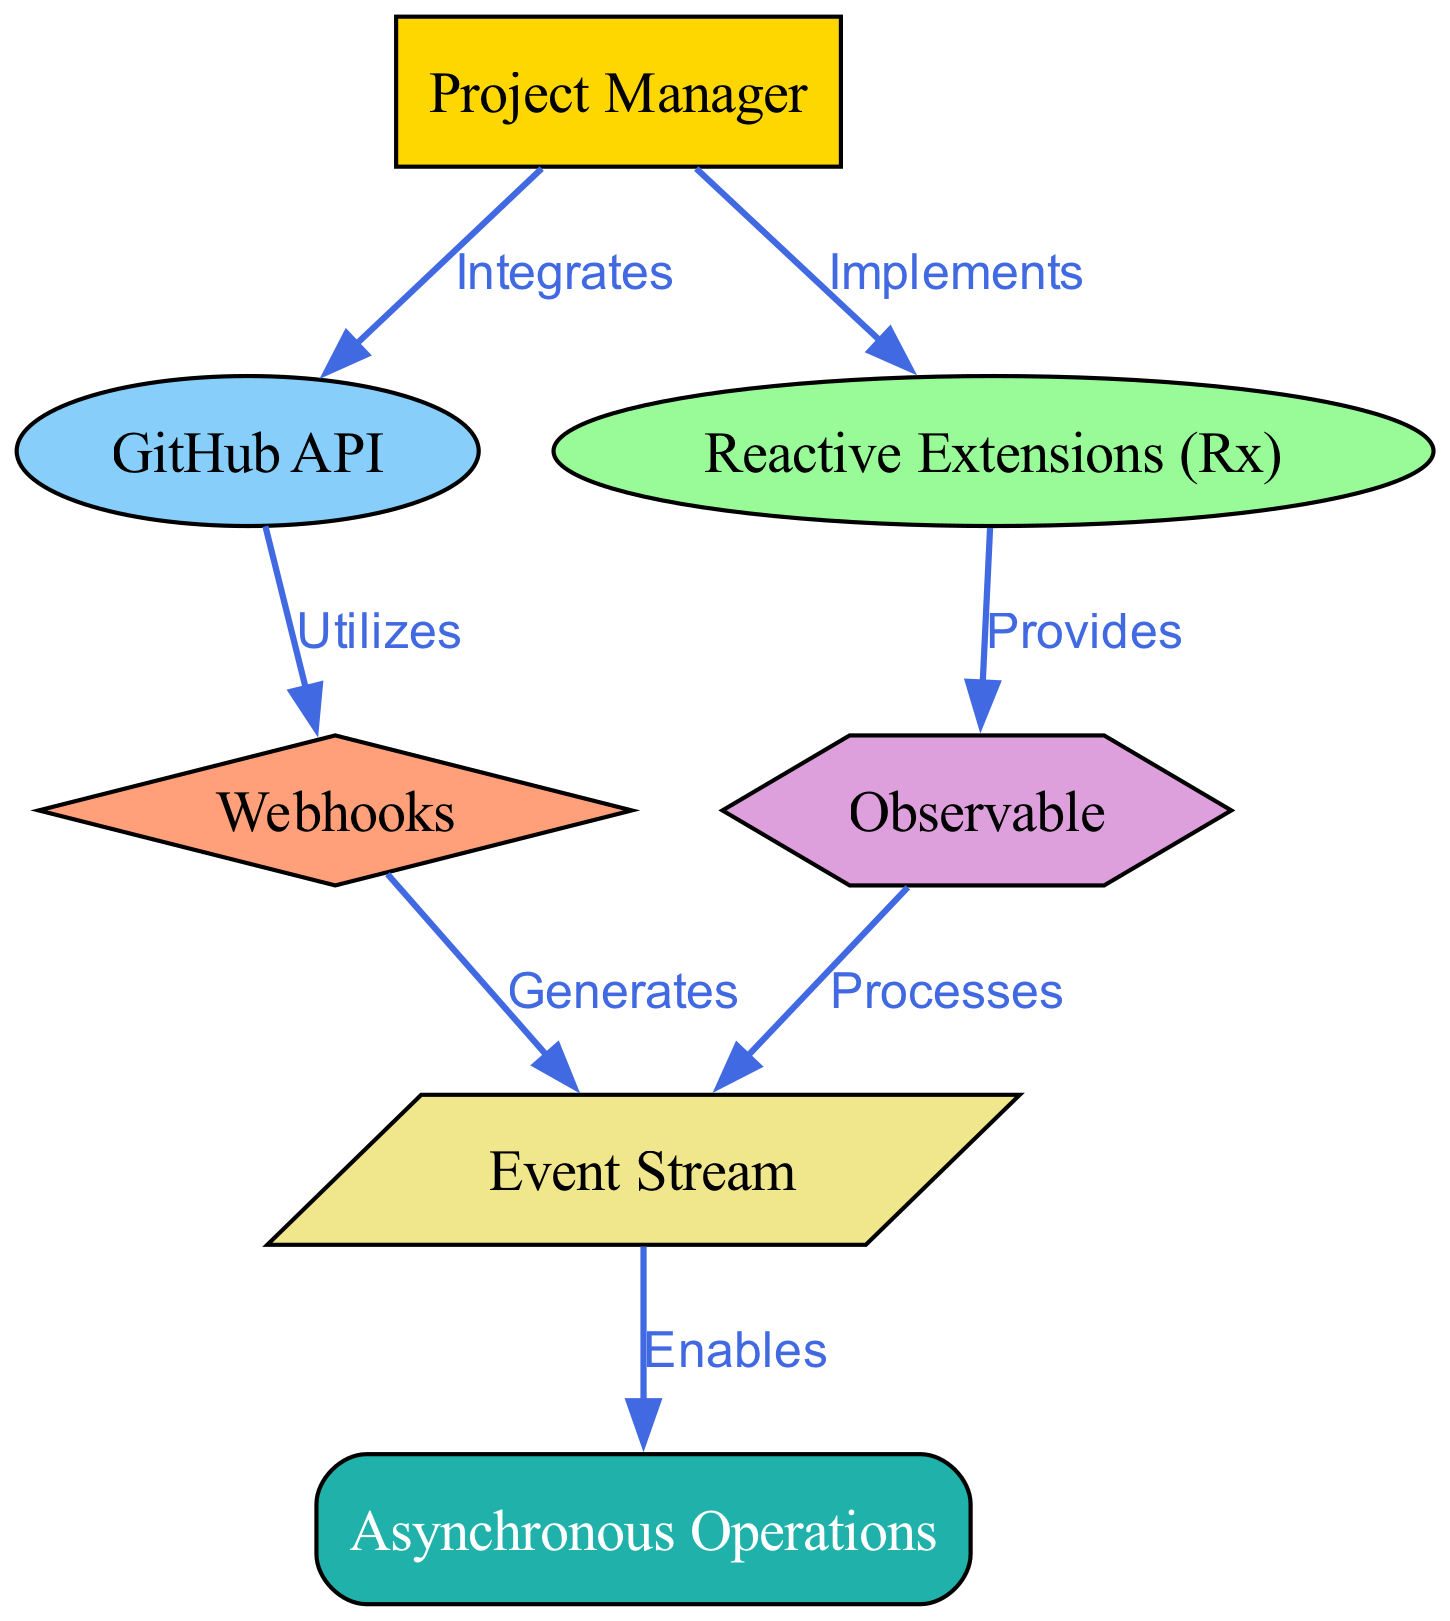What is the number of nodes in the diagram? The diagram has a total of 7 nodes, represented by the labels: Project Manager, GitHub API, Reactive Extensions (Rx), Webhooks, Observable, Event Stream, and Asynchronous Operations.
Answer: 7 What relationship exists between the Project Manager and GitHub API? The edge between the Project Manager and GitHub API is labeled "Integrates," indicating that the Project Manager integrates the GitHub API into their work.
Answer: Integrates Which node is responsible for generating Event Streams? The Webhooks node is labeled as generating Event Streams, showing the direct connection from Webhooks to Event Stream.
Answer: Webhooks What does Reactive Extensions provide according to the diagram? Reactive Extensions is connected to the Observable node with the label "Provides," indicating it provides Observable functionality.
Answer: Observable How many edges are there in total? By counting the connections between the nodes, there are 6 edges connecting the various nodes in the diagram.
Answer: 6 Which two nodes are processed by the Observable? The edges indicate that Observable processes Event Stream and also connects to the Reactive Extensions node for processing. The question is asking for the nodes that Observable directly influences or connects to, which are Event Stream.
Answer: Event Stream How does the Event Stream enable asynchronous operations? The connection from Event Stream to Asynchronous Operations indicates that the Event Stream enables these operations, defining a clear flow from event data to asynchronous functions.
Answer: Enables What does the Project Manager implement in the context of the diagram? The Project Manager is labeled as implementing Reactive Extensions, denoting their role in utilizing this technology.
Answer: Reactive Extensions What is the shape of the Observables node? The Observable is represented as a hexagon shape in the diagram, which distinguishes it from other types of nodes.
Answer: Hexagon 